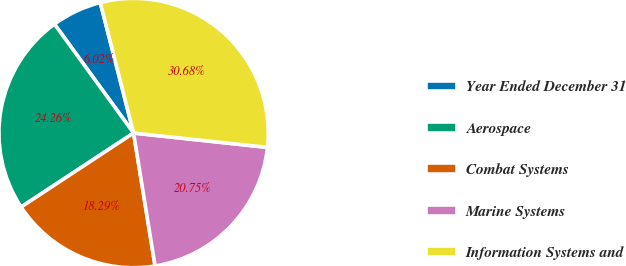Convert chart. <chart><loc_0><loc_0><loc_500><loc_500><pie_chart><fcel>Year Ended December 31<fcel>Aerospace<fcel>Combat Systems<fcel>Marine Systems<fcel>Information Systems and<nl><fcel>6.02%<fcel>24.26%<fcel>18.29%<fcel>20.75%<fcel>30.68%<nl></chart> 